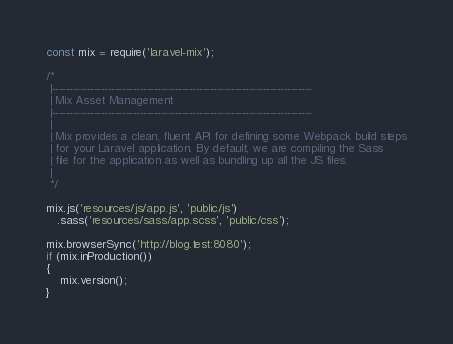<code> <loc_0><loc_0><loc_500><loc_500><_JavaScript_>const mix = require('laravel-mix');

/*
 |--------------------------------------------------------------------------
 | Mix Asset Management
 |--------------------------------------------------------------------------
 |
 | Mix provides a clean, fluent API for defining some Webpack build steps
 | for your Laravel application. By default, we are compiling the Sass
 | file for the application as well as bundling up all the JS files.
 |
 */

mix.js('resources/js/app.js', 'public/js')
   .sass('resources/sass/app.scss', 'public/css');

mix.browserSync('http://blog.test:8080');
if (mix.inProduction())
{
	mix.version();
}</code> 